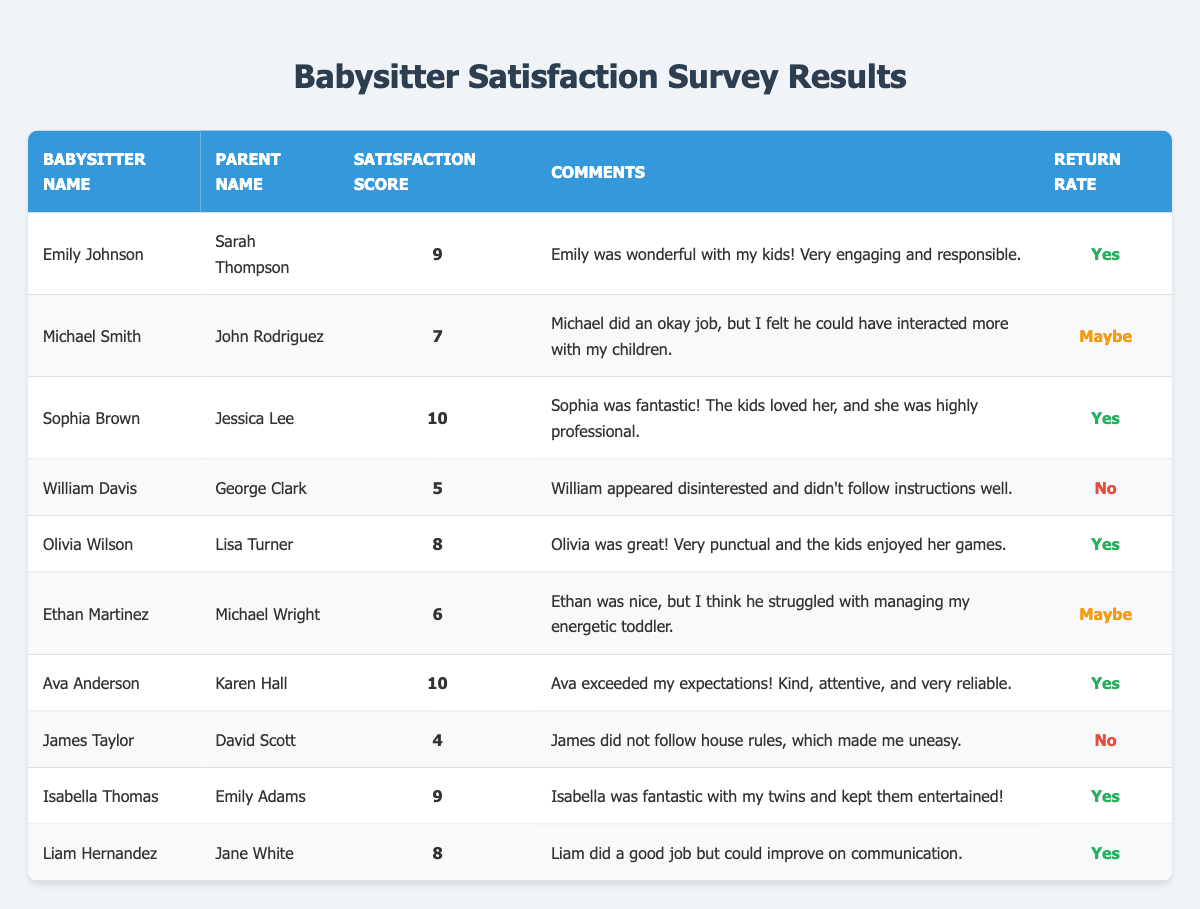What is the satisfaction score of Sophia Brown? In the table, I can find Sophia Brown's entry, where her satisfaction score is listed. It directly states that her satisfaction score is 10.
Answer: 10 How many babysitters received a satisfaction score of 9 or higher? I will count the number of babysitters with a satisfaction score of 9 or above. The scores of the babysitters are: Emily Johnson (9), Sophia Brown (10), Ava Anderson (10), and Isabella Thomas (9). This gives me a total of four babysitters.
Answer: 4 What comments did Olivia Wilson receive from Lisa Turner? By looking at the table, I see Olivia Wilson listed under the comments section, where it states that Olivia was great, very punctual, and the kids enjoyed her games.
Answer: Olivia was great! Very punctual and the kids enjoyed her games Did Michael Smith receive a “Yes” for the return rate? I will check the return rate for Michael Smith in the table. It is stated that the return rate for him is "Maybe," which indicates that he did not receive a "Yes."
Answer: No What is the average satisfaction score of all the babysitters? I will sum the satisfaction scores: (9 + 7 + 10 + 5 + 8 + 6 + 10 + 4 + 9 + 8) = 76. Then I divide the total by the number of babysitters, which is 10, so the average is 76/10 = 7.6.
Answer: 7.6 Which babysitter received the lowest satisfaction score, and what was it? Looking through the satisfaction scores in the table, James Taylor has the lowest score listed at 4.
Answer: James Taylor, 4 Based on the comments, which babysitter appears to be highly engaging with children? I will look through the comments for indications of engagement. Emily Johnson and Sophia Brown received positive feedback about being wonderful and fantastic with kids, respectively. Sophia received the highest score, indicating her high engagement.
Answer: Sophia Brown If a parent is looking for a babysitter who is guaranteed to return, which babysitters can they choose? I need to examine the return rates. The babysitters with a "Yes" return rate are Emily Johnson, Sophia Brown, Olivia Wilson, Ava Anderson, Isabella Thomas, and Liam Hernandez. This gives a total of six babysitters.
Answer: 6 What percentage of babysitters were rated below 7? First, I count the babysitters rated below 7: William Davis (5), Ethan Martinez (6), and James Taylor (4) which totals 3 babysitters. Since there are 10 babysitters in total, I calculate (3/10) * 100 = 30%.
Answer: 30% Are there more babysitters with a return rate of "Yes" or "No"? I will count the babysitters with each return rate. There are six with a "Yes" return rate (Emily, Sophia, Olivia, Ava, Isabella, Liam) and three with a "No" (William and James). Since 6 is greater than 3, there are more with "Yes".
Answer: Yes 